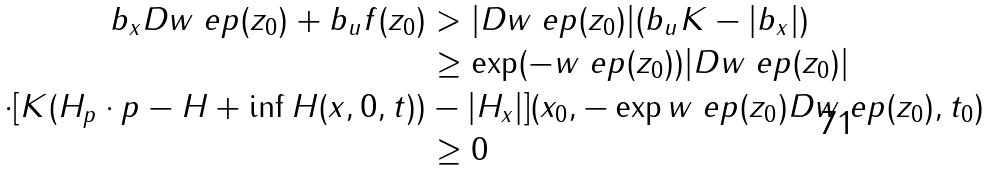<formula> <loc_0><loc_0><loc_500><loc_500>b _ { x } D w _ { \ } e p ( z _ { 0 } ) + b _ { u } f ( z _ { 0 } ) & > | D w _ { \ } e p ( z _ { 0 } ) | ( b _ { u } K - | b _ { x } | ) \\ & \geq \exp ( - w _ { \ } e p ( z _ { 0 } ) ) | D w _ { \ } e p ( z _ { 0 } ) | \\ \cdot [ K ( H _ { p } \cdot p - H + \inf H ( x , 0 , t ) ) & - | H _ { x } | ] ( x _ { 0 } , - \exp w _ { \ } e p ( z _ { 0 } ) D w _ { \ } e p ( z _ { 0 } ) , t _ { 0 } ) \\ & \geq 0</formula> 